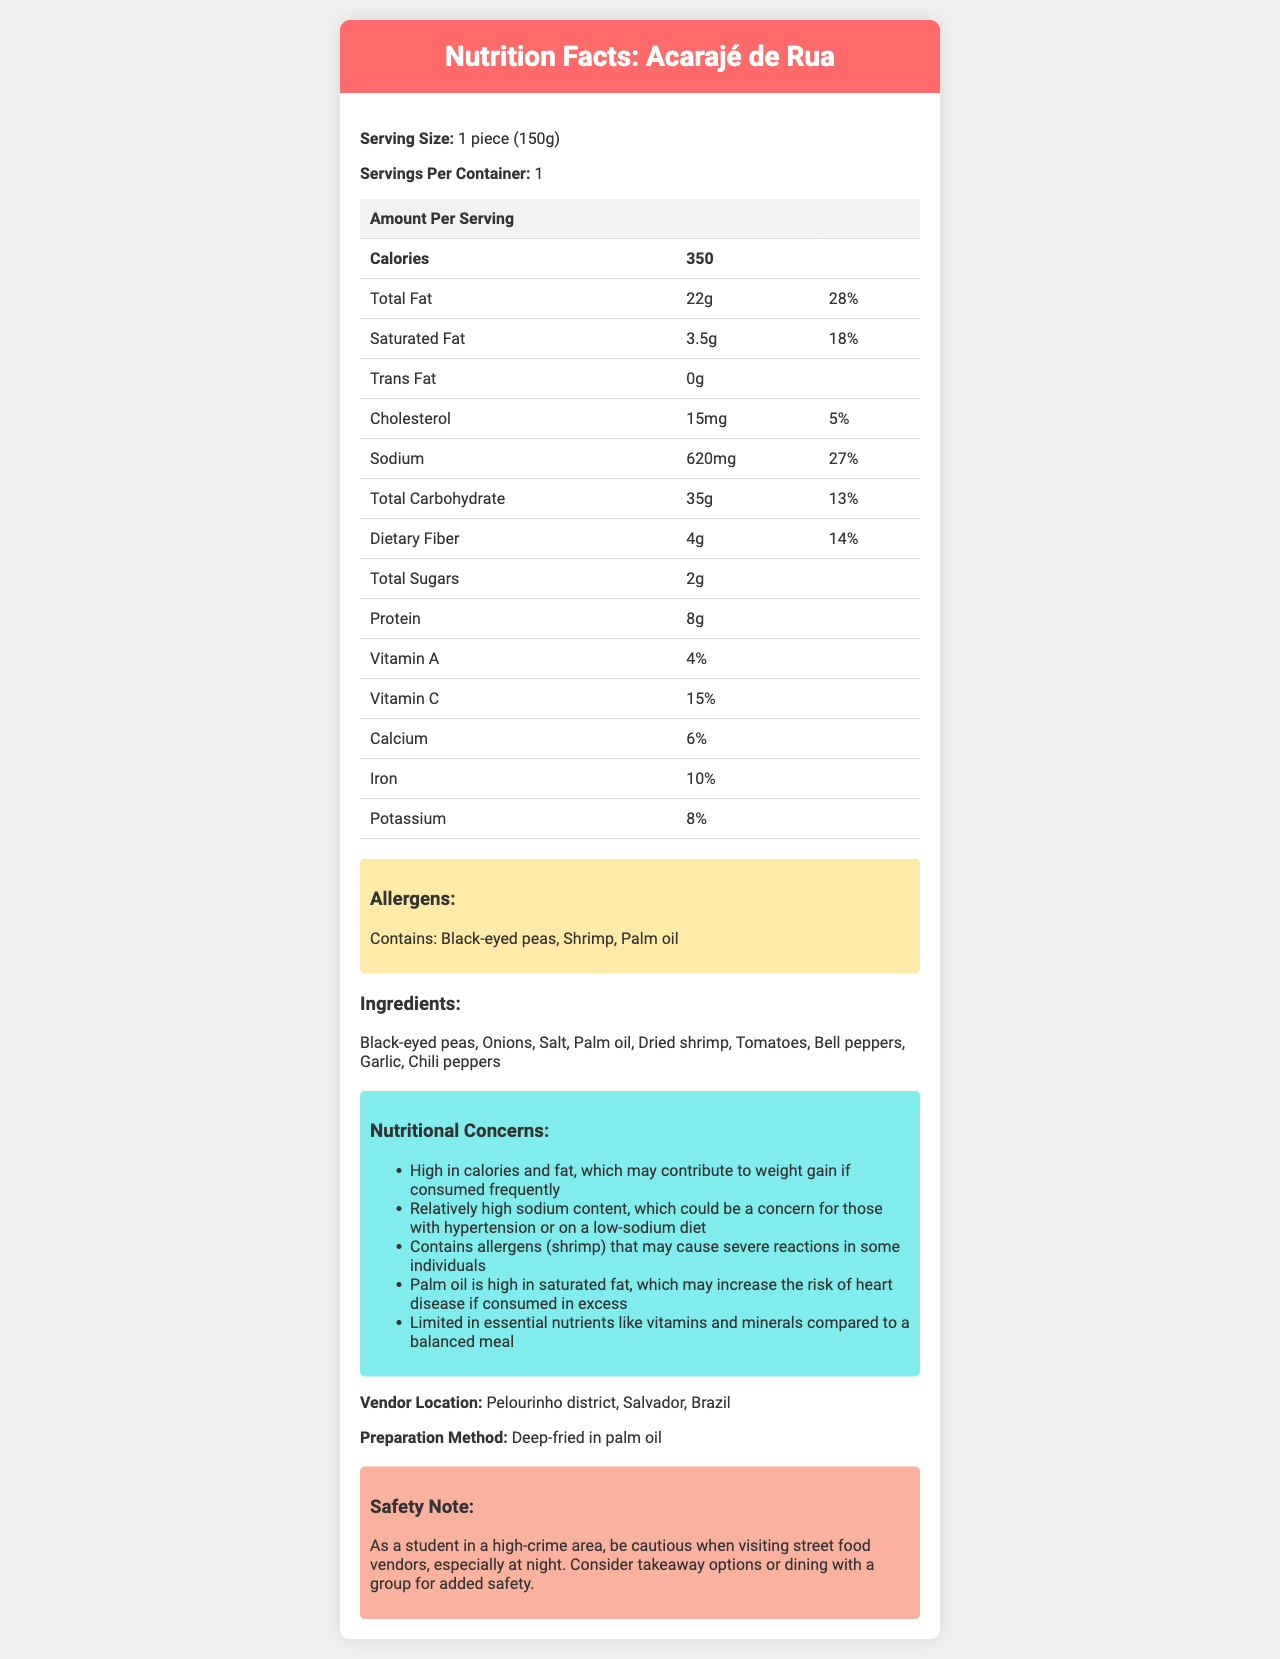what is the serving size of Acarajé de Rua? The document mentions the serving size as "1 piece (150g)" under the serving size section.
Answer: 1 piece (150g) how many calories are in one serving of Acarajé de Rua? The document lists the calories as 350 in the nutrition facts table.
Answer: 350 what is the amount of total fat in one serving? The total fat amount in one serving is stated as "22g" in the nutrition facts table.
Answer: 22g what are the main nutritional concerns mentioned for this dish? The concerns are listed under the "Nutritional Concerns" section.
Answer: High in calories and fat, relatively high sodium content, contains allergens (shrimp), high in saturated fat, limited essential nutrients how much sodium does one serving contain? The sodium content is listed as "620mg" in the nutrition facts table.
Answer: 620mg which of the following is NOT listed as an allergen? A. Shrimp B. Palm oil C. Nuts The listed allergens in the document are black-eyed peas, shrimp, and palm oil. Nuts are not listed as an allergen.
Answer: C. Nuts how much of the daily value for saturated fat does one serving provide? A. 13% B. 18% C. 22% The daily value for saturated fat is listed as "18%" in the nutrition facts table.
Answer: B. 18% is there any trans fat in Acarajé de Rua? The document lists trans fat as "0g", indicating no trans fat.
Answer: No what is the protein content in one serving of Acarajé de Rua? The protein content is listed as "8g" in the nutrition facts table.
Answer: 8g what vitamins and minerals are present in Acarajé de Rua? These are listed under the nutrition table for their respective daily values.
Answer: Vitamin A, Vitamin C, Calcium, Iron, Potassium what is the vendor location for this dish? The vendor location is mentioned under the "Vendor Location" section.
Answer: Pelourinho district, Salvador, Brazil why might someone with hypertension need to be cautious about consuming Acarajé de Rua? The document states that the dish is relatively high in sodium, which could be a concern for those with hypertension.
Answer: High sodium content summarize the nutritional information and safety concerns for Acarajé de Rua. The dish has specific nutritional concerns, including high calorie and fat content, significant sodium levels, and allergens. It is prepared via deep-frying, using palm oil which adds to the saturated fat. The document also advises safety measures due to the vendor's location in a high-crime area.
Answer: The dish is high in calories and fat, with significant sodium levels, and contains allergens (shrimp). It is deep-fried in palm oil, contributing to saturated fat content. While it provides some vitamins and minerals, it may pose concerns for weight gain, heart health, and hypertension. Caution is advised when visiting the vendor due to the high-crime area, especially at night. what is the total fiber content per serving? The dietary fiber content is stated as "4g" in the nutrition facts table.
Answer: 4g does Acarajé de Rua contribute significantly to daily essential nutrients intake? Although it provides some vitamins and minerals, the document mentions it is limited in essential nutrients compared to a balanced meal.
Answer: No what is the primary cooking method for Acarajé de Rua? The dish is prepared by deep-frying in palm oil, as mentioned in the preparation method section.
Answer: Deep-fried in palm oil can you determine the exact number of black-eyed peas used per serving? The document lists black-eyed peas as an ingredient but does not specify the exact quantity per serving.
Answer: Cannot be determined when should you be cautious of the street food vendor's location? The safety note advises caution when visiting the vendor, especially at night, due to the high-crime area.
Answer: At night 